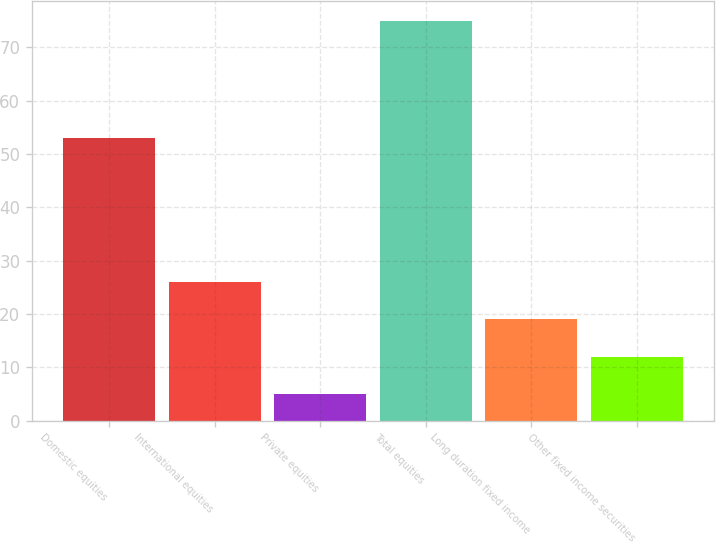Convert chart to OTSL. <chart><loc_0><loc_0><loc_500><loc_500><bar_chart><fcel>Domestic equities<fcel>International equities<fcel>Private equities<fcel>Total equities<fcel>Long duration fixed income<fcel>Other fixed income securities<nl><fcel>53<fcel>26<fcel>5<fcel>75<fcel>19<fcel>12<nl></chart> 